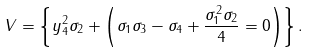Convert formula to latex. <formula><loc_0><loc_0><loc_500><loc_500>V = \left \{ y _ { 4 } ^ { 2 } \sigma _ { 2 } + \left ( \sigma _ { 1 } \sigma _ { 3 } - \sigma _ { 4 } + \frac { \sigma _ { 1 } ^ { 2 } \sigma _ { 2 } } { 4 } = 0 \right ) \right \} .</formula> 